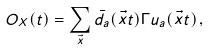<formula> <loc_0><loc_0><loc_500><loc_500>O _ { X } ( t ) = \sum _ { \vec { x } } \bar { d } _ { a } ( \vec { x } t ) \Gamma u _ { a } ( \vec { x } t ) \, ,</formula> 